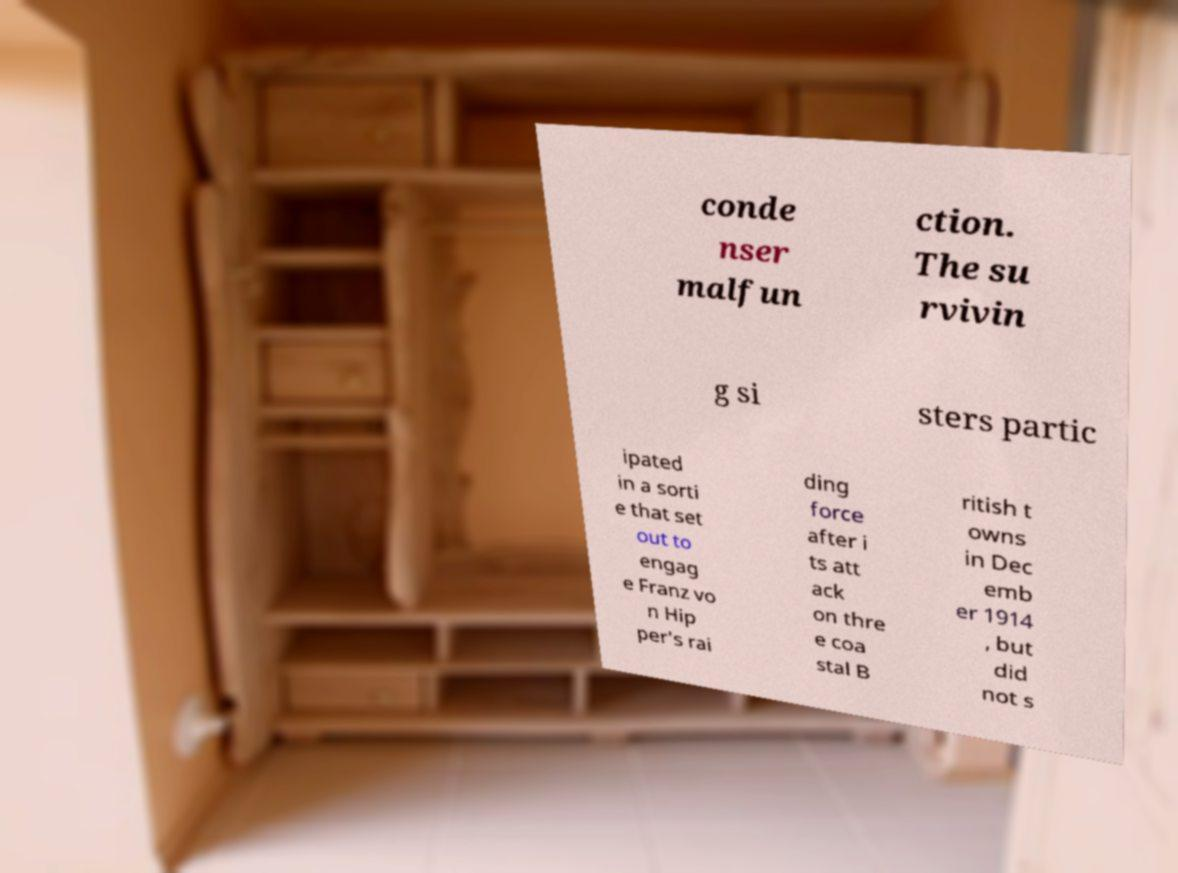Can you read and provide the text displayed in the image?This photo seems to have some interesting text. Can you extract and type it out for me? conde nser malfun ction. The su rvivin g si sters partic ipated in a sorti e that set out to engag e Franz vo n Hip per's rai ding force after i ts att ack on thre e coa stal B ritish t owns in Dec emb er 1914 , but did not s 